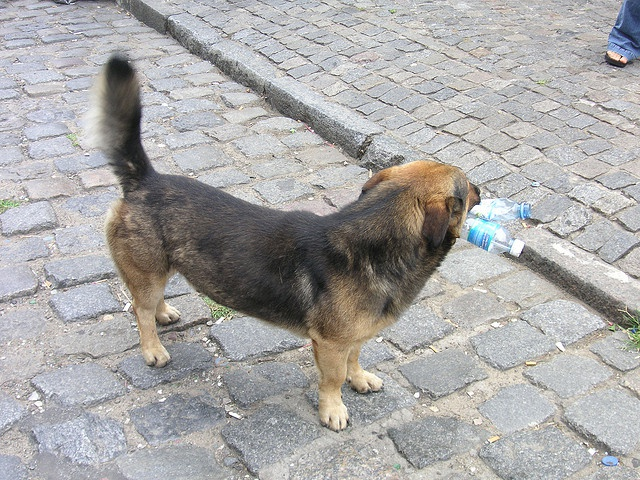Describe the objects in this image and their specific colors. I can see dog in gray, black, tan, and darkgray tones, people in gray, darkblue, navy, and darkgray tones, bottle in gray, white, lightblue, and darkgray tones, and bottle in gray, white, lightblue, and darkgray tones in this image. 